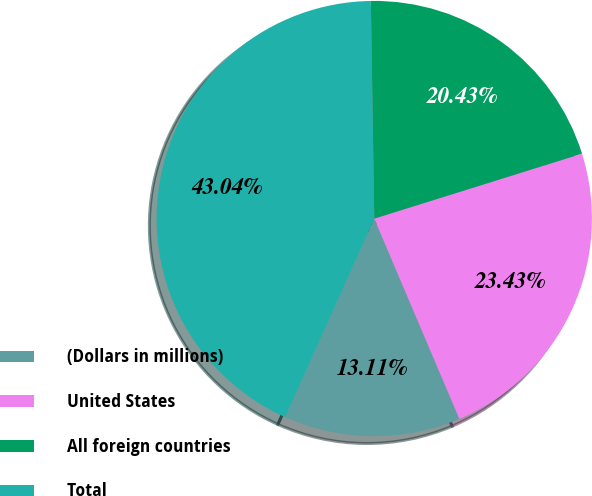Convert chart to OTSL. <chart><loc_0><loc_0><loc_500><loc_500><pie_chart><fcel>(Dollars in millions)<fcel>United States<fcel>All foreign countries<fcel>Total<nl><fcel>13.11%<fcel>23.43%<fcel>20.43%<fcel>43.04%<nl></chart> 